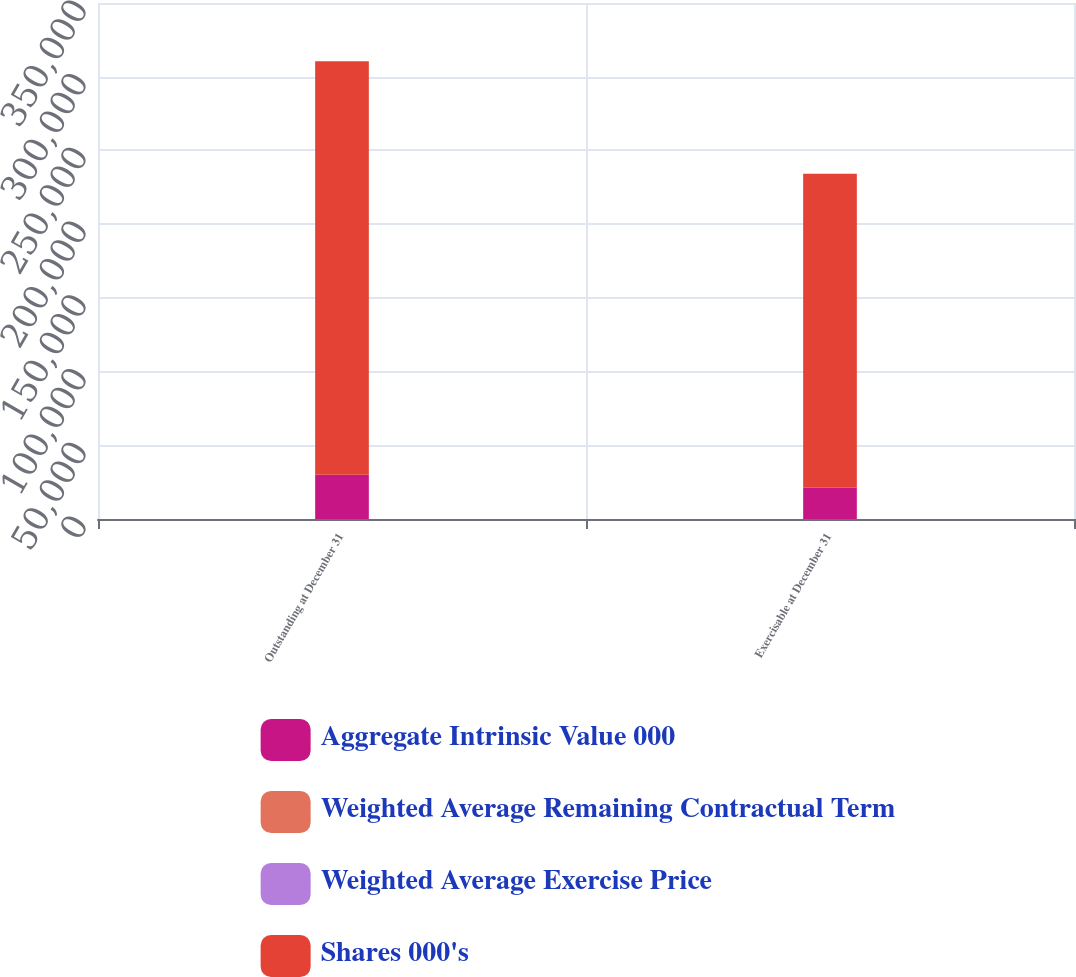Convert chart. <chart><loc_0><loc_0><loc_500><loc_500><stacked_bar_chart><ecel><fcel>Outstanding at December 31<fcel>Exercisable at December 31<nl><fcel>Aggregate Intrinsic Value 000<fcel>29950<fcel>21125<nl><fcel>Weighted Average Remaining Contractual Term<fcel>58.58<fcel>57.87<nl><fcel>Weighted Average Exercise Price<fcel>5.5<fcel>4.2<nl><fcel>Shares 000's<fcel>280510<fcel>212965<nl></chart> 